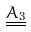Convert formula to latex. <formula><loc_0><loc_0><loc_500><loc_500>\underline { \underline { A _ { 3 } } }</formula> 